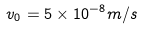<formula> <loc_0><loc_0><loc_500><loc_500>v _ { 0 } = 5 \times 1 0 ^ { - 8 } m / s</formula> 